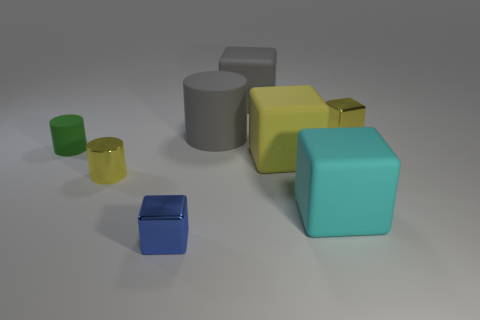Subtract all blue blocks. How many blocks are left? 4 Subtract all purple blocks. Subtract all gray spheres. How many blocks are left? 5 Add 1 yellow metallic cubes. How many objects exist? 9 Subtract all cubes. How many objects are left? 3 Subtract all large green matte cylinders. Subtract all cyan blocks. How many objects are left? 7 Add 3 rubber cylinders. How many rubber cylinders are left? 5 Add 7 large gray rubber blocks. How many large gray rubber blocks exist? 8 Subtract 1 gray cylinders. How many objects are left? 7 